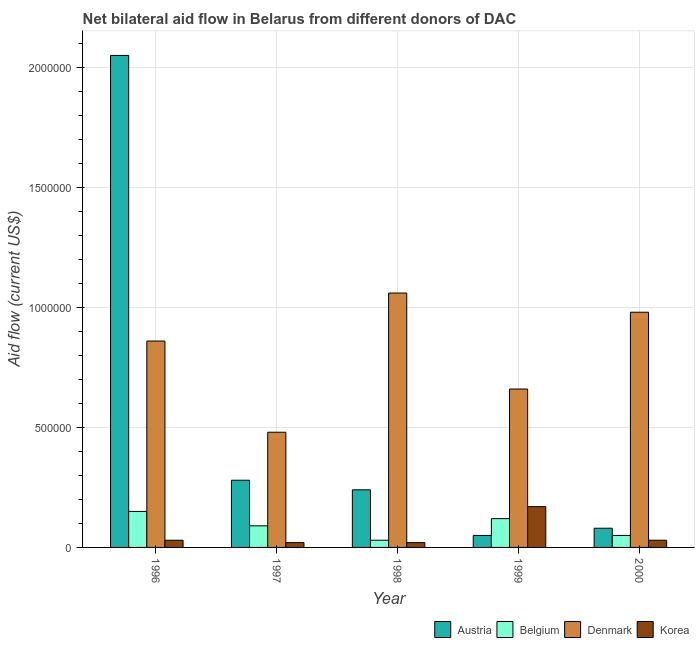How many bars are there on the 2nd tick from the left?
Ensure brevity in your answer.  4. How many bars are there on the 3rd tick from the right?
Keep it short and to the point. 4. What is the label of the 3rd group of bars from the left?
Give a very brief answer. 1998. In how many cases, is the number of bars for a given year not equal to the number of legend labels?
Your answer should be very brief. 0. What is the amount of aid given by korea in 1999?
Give a very brief answer. 1.70e+05. Across all years, what is the maximum amount of aid given by denmark?
Your response must be concise. 1.06e+06. Across all years, what is the minimum amount of aid given by belgium?
Ensure brevity in your answer.  3.00e+04. What is the total amount of aid given by austria in the graph?
Make the answer very short. 2.70e+06. What is the difference between the amount of aid given by denmark in 1997 and that in 1999?
Your response must be concise. -1.80e+05. What is the difference between the amount of aid given by korea in 1999 and the amount of aid given by belgium in 2000?
Your answer should be very brief. 1.40e+05. What is the average amount of aid given by denmark per year?
Your answer should be very brief. 8.08e+05. What is the ratio of the amount of aid given by denmark in 1996 to that in 2000?
Give a very brief answer. 0.88. Is the amount of aid given by korea in 1998 less than that in 2000?
Offer a terse response. Yes. Is the difference between the amount of aid given by denmark in 1998 and 2000 greater than the difference between the amount of aid given by korea in 1998 and 2000?
Offer a terse response. No. What is the difference between the highest and the second highest amount of aid given by austria?
Provide a short and direct response. 1.77e+06. What is the difference between the highest and the lowest amount of aid given by belgium?
Keep it short and to the point. 1.20e+05. In how many years, is the amount of aid given by belgium greater than the average amount of aid given by belgium taken over all years?
Make the answer very short. 3. Is it the case that in every year, the sum of the amount of aid given by denmark and amount of aid given by belgium is greater than the sum of amount of aid given by austria and amount of aid given by korea?
Keep it short and to the point. No. Is it the case that in every year, the sum of the amount of aid given by austria and amount of aid given by belgium is greater than the amount of aid given by denmark?
Offer a very short reply. No. Are the values on the major ticks of Y-axis written in scientific E-notation?
Keep it short and to the point. No. Does the graph contain any zero values?
Ensure brevity in your answer.  No. Where does the legend appear in the graph?
Offer a terse response. Bottom right. How many legend labels are there?
Offer a very short reply. 4. What is the title of the graph?
Make the answer very short. Net bilateral aid flow in Belarus from different donors of DAC. Does "Social Insurance" appear as one of the legend labels in the graph?
Your answer should be very brief. No. What is the label or title of the X-axis?
Ensure brevity in your answer.  Year. What is the label or title of the Y-axis?
Offer a terse response. Aid flow (current US$). What is the Aid flow (current US$) of Austria in 1996?
Make the answer very short. 2.05e+06. What is the Aid flow (current US$) of Belgium in 1996?
Your answer should be compact. 1.50e+05. What is the Aid flow (current US$) in Denmark in 1996?
Keep it short and to the point. 8.60e+05. What is the Aid flow (current US$) of Austria in 1997?
Offer a terse response. 2.80e+05. What is the Aid flow (current US$) in Denmark in 1997?
Provide a succinct answer. 4.80e+05. What is the Aid flow (current US$) of Korea in 1997?
Offer a very short reply. 2.00e+04. What is the Aid flow (current US$) of Denmark in 1998?
Your answer should be very brief. 1.06e+06. What is the Aid flow (current US$) of Korea in 1998?
Ensure brevity in your answer.  2.00e+04. What is the Aid flow (current US$) of Austria in 1999?
Provide a short and direct response. 5.00e+04. What is the Aid flow (current US$) in Belgium in 1999?
Provide a succinct answer. 1.20e+05. What is the Aid flow (current US$) in Denmark in 2000?
Offer a very short reply. 9.80e+05. Across all years, what is the maximum Aid flow (current US$) in Austria?
Your response must be concise. 2.05e+06. Across all years, what is the maximum Aid flow (current US$) in Denmark?
Ensure brevity in your answer.  1.06e+06. Across all years, what is the maximum Aid flow (current US$) in Korea?
Provide a short and direct response. 1.70e+05. What is the total Aid flow (current US$) of Austria in the graph?
Make the answer very short. 2.70e+06. What is the total Aid flow (current US$) in Belgium in the graph?
Ensure brevity in your answer.  4.40e+05. What is the total Aid flow (current US$) of Denmark in the graph?
Ensure brevity in your answer.  4.04e+06. What is the total Aid flow (current US$) in Korea in the graph?
Give a very brief answer. 2.70e+05. What is the difference between the Aid flow (current US$) in Austria in 1996 and that in 1997?
Offer a very short reply. 1.77e+06. What is the difference between the Aid flow (current US$) of Korea in 1996 and that in 1997?
Keep it short and to the point. 10000. What is the difference between the Aid flow (current US$) of Austria in 1996 and that in 1998?
Provide a short and direct response. 1.81e+06. What is the difference between the Aid flow (current US$) of Denmark in 1996 and that in 1998?
Give a very brief answer. -2.00e+05. What is the difference between the Aid flow (current US$) in Korea in 1996 and that in 1998?
Offer a terse response. 10000. What is the difference between the Aid flow (current US$) in Denmark in 1996 and that in 1999?
Offer a terse response. 2.00e+05. What is the difference between the Aid flow (current US$) of Austria in 1996 and that in 2000?
Provide a succinct answer. 1.97e+06. What is the difference between the Aid flow (current US$) of Denmark in 1996 and that in 2000?
Your response must be concise. -1.20e+05. What is the difference between the Aid flow (current US$) of Denmark in 1997 and that in 1998?
Offer a terse response. -5.80e+05. What is the difference between the Aid flow (current US$) of Austria in 1997 and that in 2000?
Your response must be concise. 2.00e+05. What is the difference between the Aid flow (current US$) in Denmark in 1997 and that in 2000?
Provide a succinct answer. -5.00e+05. What is the difference between the Aid flow (current US$) in Korea in 1997 and that in 2000?
Make the answer very short. -10000. What is the difference between the Aid flow (current US$) of Belgium in 1998 and that in 1999?
Offer a terse response. -9.00e+04. What is the difference between the Aid flow (current US$) in Denmark in 1998 and that in 1999?
Offer a very short reply. 4.00e+05. What is the difference between the Aid flow (current US$) of Belgium in 1998 and that in 2000?
Keep it short and to the point. -2.00e+04. What is the difference between the Aid flow (current US$) of Austria in 1999 and that in 2000?
Give a very brief answer. -3.00e+04. What is the difference between the Aid flow (current US$) of Denmark in 1999 and that in 2000?
Your response must be concise. -3.20e+05. What is the difference between the Aid flow (current US$) of Austria in 1996 and the Aid flow (current US$) of Belgium in 1997?
Offer a terse response. 1.96e+06. What is the difference between the Aid flow (current US$) in Austria in 1996 and the Aid flow (current US$) in Denmark in 1997?
Provide a short and direct response. 1.57e+06. What is the difference between the Aid flow (current US$) in Austria in 1996 and the Aid flow (current US$) in Korea in 1997?
Give a very brief answer. 2.03e+06. What is the difference between the Aid flow (current US$) in Belgium in 1996 and the Aid flow (current US$) in Denmark in 1997?
Provide a short and direct response. -3.30e+05. What is the difference between the Aid flow (current US$) of Denmark in 1996 and the Aid flow (current US$) of Korea in 1997?
Keep it short and to the point. 8.40e+05. What is the difference between the Aid flow (current US$) in Austria in 1996 and the Aid flow (current US$) in Belgium in 1998?
Provide a short and direct response. 2.02e+06. What is the difference between the Aid flow (current US$) of Austria in 1996 and the Aid flow (current US$) of Denmark in 1998?
Offer a very short reply. 9.90e+05. What is the difference between the Aid flow (current US$) of Austria in 1996 and the Aid flow (current US$) of Korea in 1998?
Offer a terse response. 2.03e+06. What is the difference between the Aid flow (current US$) of Belgium in 1996 and the Aid flow (current US$) of Denmark in 1998?
Give a very brief answer. -9.10e+05. What is the difference between the Aid flow (current US$) of Denmark in 1996 and the Aid flow (current US$) of Korea in 1998?
Make the answer very short. 8.40e+05. What is the difference between the Aid flow (current US$) in Austria in 1996 and the Aid flow (current US$) in Belgium in 1999?
Give a very brief answer. 1.93e+06. What is the difference between the Aid flow (current US$) of Austria in 1996 and the Aid flow (current US$) of Denmark in 1999?
Provide a succinct answer. 1.39e+06. What is the difference between the Aid flow (current US$) in Austria in 1996 and the Aid flow (current US$) in Korea in 1999?
Your answer should be compact. 1.88e+06. What is the difference between the Aid flow (current US$) of Belgium in 1996 and the Aid flow (current US$) of Denmark in 1999?
Keep it short and to the point. -5.10e+05. What is the difference between the Aid flow (current US$) in Belgium in 1996 and the Aid flow (current US$) in Korea in 1999?
Your answer should be very brief. -2.00e+04. What is the difference between the Aid flow (current US$) of Denmark in 1996 and the Aid flow (current US$) of Korea in 1999?
Offer a terse response. 6.90e+05. What is the difference between the Aid flow (current US$) of Austria in 1996 and the Aid flow (current US$) of Denmark in 2000?
Keep it short and to the point. 1.07e+06. What is the difference between the Aid flow (current US$) of Austria in 1996 and the Aid flow (current US$) of Korea in 2000?
Provide a short and direct response. 2.02e+06. What is the difference between the Aid flow (current US$) in Belgium in 1996 and the Aid flow (current US$) in Denmark in 2000?
Your answer should be very brief. -8.30e+05. What is the difference between the Aid flow (current US$) in Denmark in 1996 and the Aid flow (current US$) in Korea in 2000?
Keep it short and to the point. 8.30e+05. What is the difference between the Aid flow (current US$) in Austria in 1997 and the Aid flow (current US$) in Belgium in 1998?
Provide a succinct answer. 2.50e+05. What is the difference between the Aid flow (current US$) in Austria in 1997 and the Aid flow (current US$) in Denmark in 1998?
Ensure brevity in your answer.  -7.80e+05. What is the difference between the Aid flow (current US$) in Belgium in 1997 and the Aid flow (current US$) in Denmark in 1998?
Your answer should be compact. -9.70e+05. What is the difference between the Aid flow (current US$) of Belgium in 1997 and the Aid flow (current US$) of Korea in 1998?
Your response must be concise. 7.00e+04. What is the difference between the Aid flow (current US$) in Denmark in 1997 and the Aid flow (current US$) in Korea in 1998?
Your answer should be compact. 4.60e+05. What is the difference between the Aid flow (current US$) of Austria in 1997 and the Aid flow (current US$) of Denmark in 1999?
Provide a succinct answer. -3.80e+05. What is the difference between the Aid flow (current US$) in Belgium in 1997 and the Aid flow (current US$) in Denmark in 1999?
Offer a terse response. -5.70e+05. What is the difference between the Aid flow (current US$) in Belgium in 1997 and the Aid flow (current US$) in Korea in 1999?
Ensure brevity in your answer.  -8.00e+04. What is the difference between the Aid flow (current US$) in Austria in 1997 and the Aid flow (current US$) in Belgium in 2000?
Make the answer very short. 2.30e+05. What is the difference between the Aid flow (current US$) of Austria in 1997 and the Aid flow (current US$) of Denmark in 2000?
Ensure brevity in your answer.  -7.00e+05. What is the difference between the Aid flow (current US$) of Austria in 1997 and the Aid flow (current US$) of Korea in 2000?
Ensure brevity in your answer.  2.50e+05. What is the difference between the Aid flow (current US$) in Belgium in 1997 and the Aid flow (current US$) in Denmark in 2000?
Make the answer very short. -8.90e+05. What is the difference between the Aid flow (current US$) of Belgium in 1997 and the Aid flow (current US$) of Korea in 2000?
Provide a short and direct response. 6.00e+04. What is the difference between the Aid flow (current US$) of Denmark in 1997 and the Aid flow (current US$) of Korea in 2000?
Your answer should be very brief. 4.50e+05. What is the difference between the Aid flow (current US$) in Austria in 1998 and the Aid flow (current US$) in Belgium in 1999?
Ensure brevity in your answer.  1.20e+05. What is the difference between the Aid flow (current US$) in Austria in 1998 and the Aid flow (current US$) in Denmark in 1999?
Provide a succinct answer. -4.20e+05. What is the difference between the Aid flow (current US$) of Belgium in 1998 and the Aid flow (current US$) of Denmark in 1999?
Your answer should be very brief. -6.30e+05. What is the difference between the Aid flow (current US$) of Denmark in 1998 and the Aid flow (current US$) of Korea in 1999?
Ensure brevity in your answer.  8.90e+05. What is the difference between the Aid flow (current US$) in Austria in 1998 and the Aid flow (current US$) in Denmark in 2000?
Ensure brevity in your answer.  -7.40e+05. What is the difference between the Aid flow (current US$) in Austria in 1998 and the Aid flow (current US$) in Korea in 2000?
Your answer should be very brief. 2.10e+05. What is the difference between the Aid flow (current US$) in Belgium in 1998 and the Aid flow (current US$) in Denmark in 2000?
Ensure brevity in your answer.  -9.50e+05. What is the difference between the Aid flow (current US$) of Belgium in 1998 and the Aid flow (current US$) of Korea in 2000?
Your answer should be very brief. 0. What is the difference between the Aid flow (current US$) in Denmark in 1998 and the Aid flow (current US$) in Korea in 2000?
Give a very brief answer. 1.03e+06. What is the difference between the Aid flow (current US$) in Austria in 1999 and the Aid flow (current US$) in Belgium in 2000?
Provide a succinct answer. 0. What is the difference between the Aid flow (current US$) of Austria in 1999 and the Aid flow (current US$) of Denmark in 2000?
Offer a very short reply. -9.30e+05. What is the difference between the Aid flow (current US$) of Belgium in 1999 and the Aid flow (current US$) of Denmark in 2000?
Your answer should be compact. -8.60e+05. What is the difference between the Aid flow (current US$) of Denmark in 1999 and the Aid flow (current US$) of Korea in 2000?
Provide a short and direct response. 6.30e+05. What is the average Aid flow (current US$) in Austria per year?
Your answer should be very brief. 5.40e+05. What is the average Aid flow (current US$) of Belgium per year?
Offer a very short reply. 8.80e+04. What is the average Aid flow (current US$) of Denmark per year?
Your response must be concise. 8.08e+05. What is the average Aid flow (current US$) of Korea per year?
Keep it short and to the point. 5.40e+04. In the year 1996, what is the difference between the Aid flow (current US$) in Austria and Aid flow (current US$) in Belgium?
Your response must be concise. 1.90e+06. In the year 1996, what is the difference between the Aid flow (current US$) in Austria and Aid flow (current US$) in Denmark?
Your response must be concise. 1.19e+06. In the year 1996, what is the difference between the Aid flow (current US$) of Austria and Aid flow (current US$) of Korea?
Your answer should be compact. 2.02e+06. In the year 1996, what is the difference between the Aid flow (current US$) in Belgium and Aid flow (current US$) in Denmark?
Your answer should be compact. -7.10e+05. In the year 1996, what is the difference between the Aid flow (current US$) in Belgium and Aid flow (current US$) in Korea?
Your response must be concise. 1.20e+05. In the year 1996, what is the difference between the Aid flow (current US$) in Denmark and Aid flow (current US$) in Korea?
Keep it short and to the point. 8.30e+05. In the year 1997, what is the difference between the Aid flow (current US$) of Austria and Aid flow (current US$) of Belgium?
Offer a terse response. 1.90e+05. In the year 1997, what is the difference between the Aid flow (current US$) in Austria and Aid flow (current US$) in Denmark?
Provide a succinct answer. -2.00e+05. In the year 1997, what is the difference between the Aid flow (current US$) of Austria and Aid flow (current US$) of Korea?
Provide a short and direct response. 2.60e+05. In the year 1997, what is the difference between the Aid flow (current US$) in Belgium and Aid flow (current US$) in Denmark?
Your answer should be compact. -3.90e+05. In the year 1998, what is the difference between the Aid flow (current US$) in Austria and Aid flow (current US$) in Belgium?
Ensure brevity in your answer.  2.10e+05. In the year 1998, what is the difference between the Aid flow (current US$) of Austria and Aid flow (current US$) of Denmark?
Keep it short and to the point. -8.20e+05. In the year 1998, what is the difference between the Aid flow (current US$) in Austria and Aid flow (current US$) in Korea?
Ensure brevity in your answer.  2.20e+05. In the year 1998, what is the difference between the Aid flow (current US$) in Belgium and Aid flow (current US$) in Denmark?
Your answer should be compact. -1.03e+06. In the year 1998, what is the difference between the Aid flow (current US$) of Denmark and Aid flow (current US$) of Korea?
Ensure brevity in your answer.  1.04e+06. In the year 1999, what is the difference between the Aid flow (current US$) of Austria and Aid flow (current US$) of Denmark?
Offer a very short reply. -6.10e+05. In the year 1999, what is the difference between the Aid flow (current US$) in Austria and Aid flow (current US$) in Korea?
Ensure brevity in your answer.  -1.20e+05. In the year 1999, what is the difference between the Aid flow (current US$) in Belgium and Aid flow (current US$) in Denmark?
Keep it short and to the point. -5.40e+05. In the year 2000, what is the difference between the Aid flow (current US$) in Austria and Aid flow (current US$) in Belgium?
Offer a terse response. 3.00e+04. In the year 2000, what is the difference between the Aid flow (current US$) in Austria and Aid flow (current US$) in Denmark?
Give a very brief answer. -9.00e+05. In the year 2000, what is the difference between the Aid flow (current US$) in Belgium and Aid flow (current US$) in Denmark?
Offer a very short reply. -9.30e+05. In the year 2000, what is the difference between the Aid flow (current US$) in Denmark and Aid flow (current US$) in Korea?
Provide a short and direct response. 9.50e+05. What is the ratio of the Aid flow (current US$) of Austria in 1996 to that in 1997?
Offer a terse response. 7.32. What is the ratio of the Aid flow (current US$) in Belgium in 1996 to that in 1997?
Give a very brief answer. 1.67. What is the ratio of the Aid flow (current US$) in Denmark in 1996 to that in 1997?
Keep it short and to the point. 1.79. What is the ratio of the Aid flow (current US$) of Korea in 1996 to that in 1997?
Provide a succinct answer. 1.5. What is the ratio of the Aid flow (current US$) of Austria in 1996 to that in 1998?
Provide a succinct answer. 8.54. What is the ratio of the Aid flow (current US$) in Denmark in 1996 to that in 1998?
Your response must be concise. 0.81. What is the ratio of the Aid flow (current US$) of Korea in 1996 to that in 1998?
Your answer should be very brief. 1.5. What is the ratio of the Aid flow (current US$) in Austria in 1996 to that in 1999?
Offer a terse response. 41. What is the ratio of the Aid flow (current US$) of Denmark in 1996 to that in 1999?
Provide a short and direct response. 1.3. What is the ratio of the Aid flow (current US$) in Korea in 1996 to that in 1999?
Your response must be concise. 0.18. What is the ratio of the Aid flow (current US$) in Austria in 1996 to that in 2000?
Make the answer very short. 25.62. What is the ratio of the Aid flow (current US$) in Belgium in 1996 to that in 2000?
Your answer should be compact. 3. What is the ratio of the Aid flow (current US$) in Denmark in 1996 to that in 2000?
Provide a succinct answer. 0.88. What is the ratio of the Aid flow (current US$) in Korea in 1996 to that in 2000?
Give a very brief answer. 1. What is the ratio of the Aid flow (current US$) in Austria in 1997 to that in 1998?
Your answer should be compact. 1.17. What is the ratio of the Aid flow (current US$) of Belgium in 1997 to that in 1998?
Your answer should be very brief. 3. What is the ratio of the Aid flow (current US$) in Denmark in 1997 to that in 1998?
Make the answer very short. 0.45. What is the ratio of the Aid flow (current US$) in Belgium in 1997 to that in 1999?
Your response must be concise. 0.75. What is the ratio of the Aid flow (current US$) in Denmark in 1997 to that in 1999?
Keep it short and to the point. 0.73. What is the ratio of the Aid flow (current US$) in Korea in 1997 to that in 1999?
Provide a succinct answer. 0.12. What is the ratio of the Aid flow (current US$) in Austria in 1997 to that in 2000?
Make the answer very short. 3.5. What is the ratio of the Aid flow (current US$) of Denmark in 1997 to that in 2000?
Make the answer very short. 0.49. What is the ratio of the Aid flow (current US$) of Austria in 1998 to that in 1999?
Make the answer very short. 4.8. What is the ratio of the Aid flow (current US$) of Denmark in 1998 to that in 1999?
Offer a very short reply. 1.61. What is the ratio of the Aid flow (current US$) of Korea in 1998 to that in 1999?
Give a very brief answer. 0.12. What is the ratio of the Aid flow (current US$) of Belgium in 1998 to that in 2000?
Keep it short and to the point. 0.6. What is the ratio of the Aid flow (current US$) in Denmark in 1998 to that in 2000?
Ensure brevity in your answer.  1.08. What is the ratio of the Aid flow (current US$) in Austria in 1999 to that in 2000?
Provide a succinct answer. 0.62. What is the ratio of the Aid flow (current US$) in Denmark in 1999 to that in 2000?
Provide a succinct answer. 0.67. What is the ratio of the Aid flow (current US$) of Korea in 1999 to that in 2000?
Make the answer very short. 5.67. What is the difference between the highest and the second highest Aid flow (current US$) of Austria?
Your answer should be compact. 1.77e+06. What is the difference between the highest and the second highest Aid flow (current US$) in Belgium?
Your answer should be compact. 3.00e+04. What is the difference between the highest and the second highest Aid flow (current US$) of Korea?
Your answer should be compact. 1.40e+05. What is the difference between the highest and the lowest Aid flow (current US$) in Austria?
Your response must be concise. 2.00e+06. What is the difference between the highest and the lowest Aid flow (current US$) in Denmark?
Ensure brevity in your answer.  5.80e+05. 